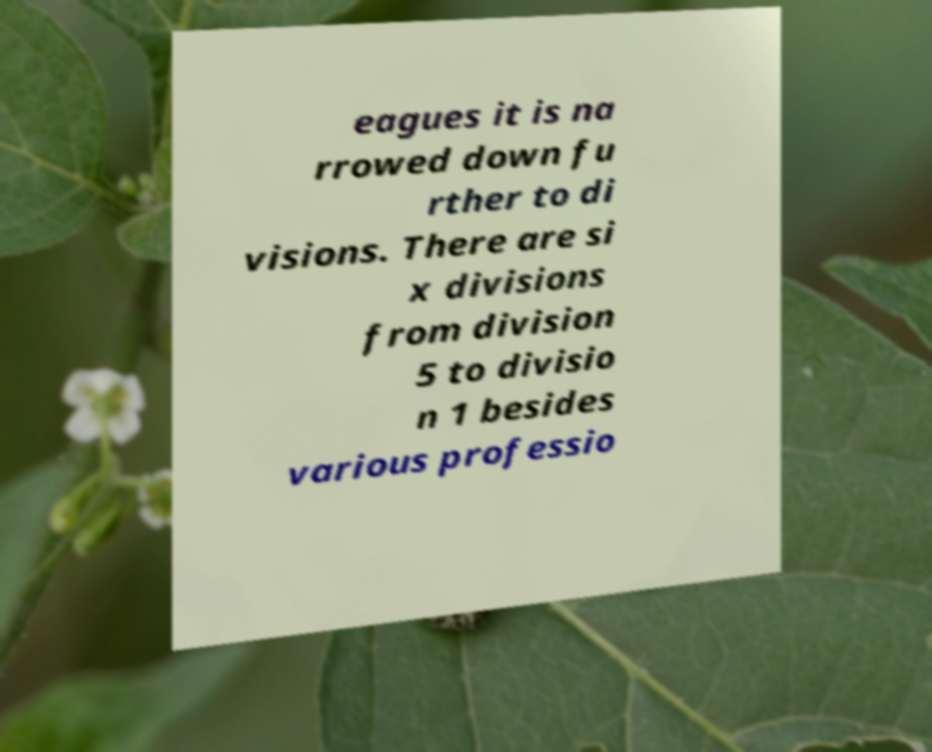Could you assist in decoding the text presented in this image and type it out clearly? eagues it is na rrowed down fu rther to di visions. There are si x divisions from division 5 to divisio n 1 besides various professio 